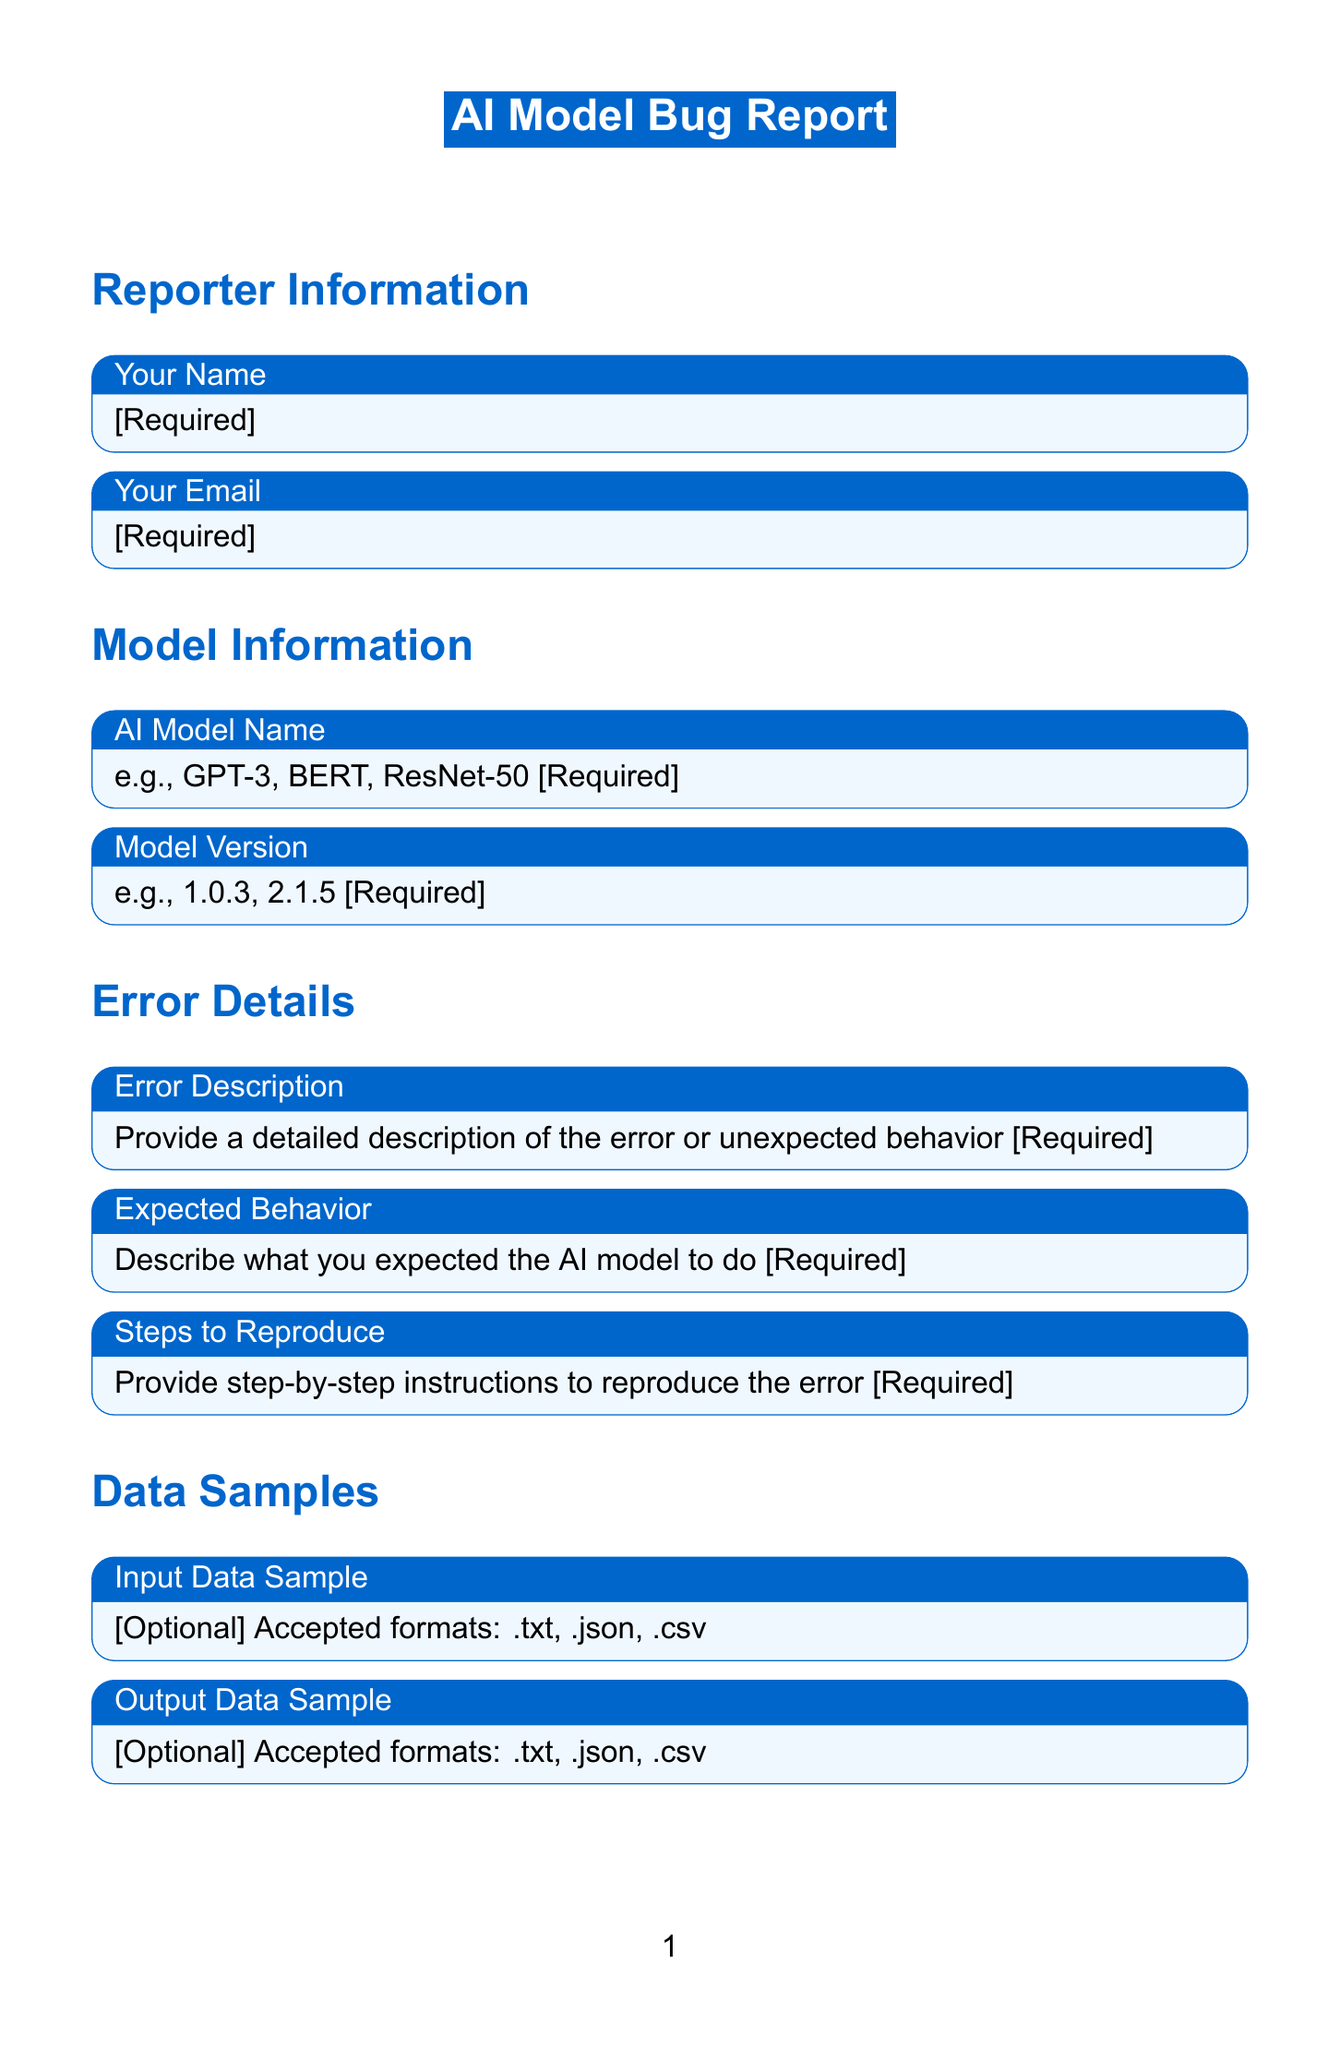What is the title of the form? The title of the form is stated at the beginning, identifying the purpose of the document.
Answer: AI Model Bug Report What is the required field for inputting the AI model name? The form specifies a mandatory field for the name of the AI model, guiding the user to provide this information.
Answer: AI Model Name What type of files can be uploaded for Input Data Sample? The document indicates accepted formats for the input data, providing clarity on what users can submit.
Answer: .txt, .json, .csv Which operating systems are mentioned in the placeholder for Operating System? The document includes examples in the placeholder to assist the user in providing appropriate information.
Answer: Ubuntu 20.04, Windows 10, macOS Big Sur What are the options available for Error Severity? The document provides a list of choices for classifying the severity of the bug, indicating the level of urgency.
Answer: Critical, High, Medium, Low What is the required information about the reporter? The form emphasizes the need to collect essential contact details from the reporter for follow-up or further communication.
Answer: Your Name, Your Email How many steps are required to reproduce the error? The form explicitly requests the user to provide detailed steps, helping to understand the issue better.
Answer: Steps to Reproduce What is the field type for Error Description? The document specifies how the users should provide information about the error, emphasizing its relevance.
Answer: textarea What is one of the optional data fields in this form? The document outlines certain optional fields where users can submit additional relevant information if available.
Answer: Error Logs 